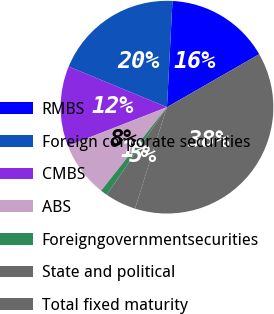<chart> <loc_0><loc_0><loc_500><loc_500><pie_chart><fcel>RMBS<fcel>Foreign corporate securities<fcel>CMBS<fcel>ABS<fcel>Foreigngovernmentsecurities<fcel>State and political<fcel>Total fixed maturity<nl><fcel>15.88%<fcel>19.59%<fcel>12.16%<fcel>8.45%<fcel>1.02%<fcel>4.74%<fcel>38.16%<nl></chart> 